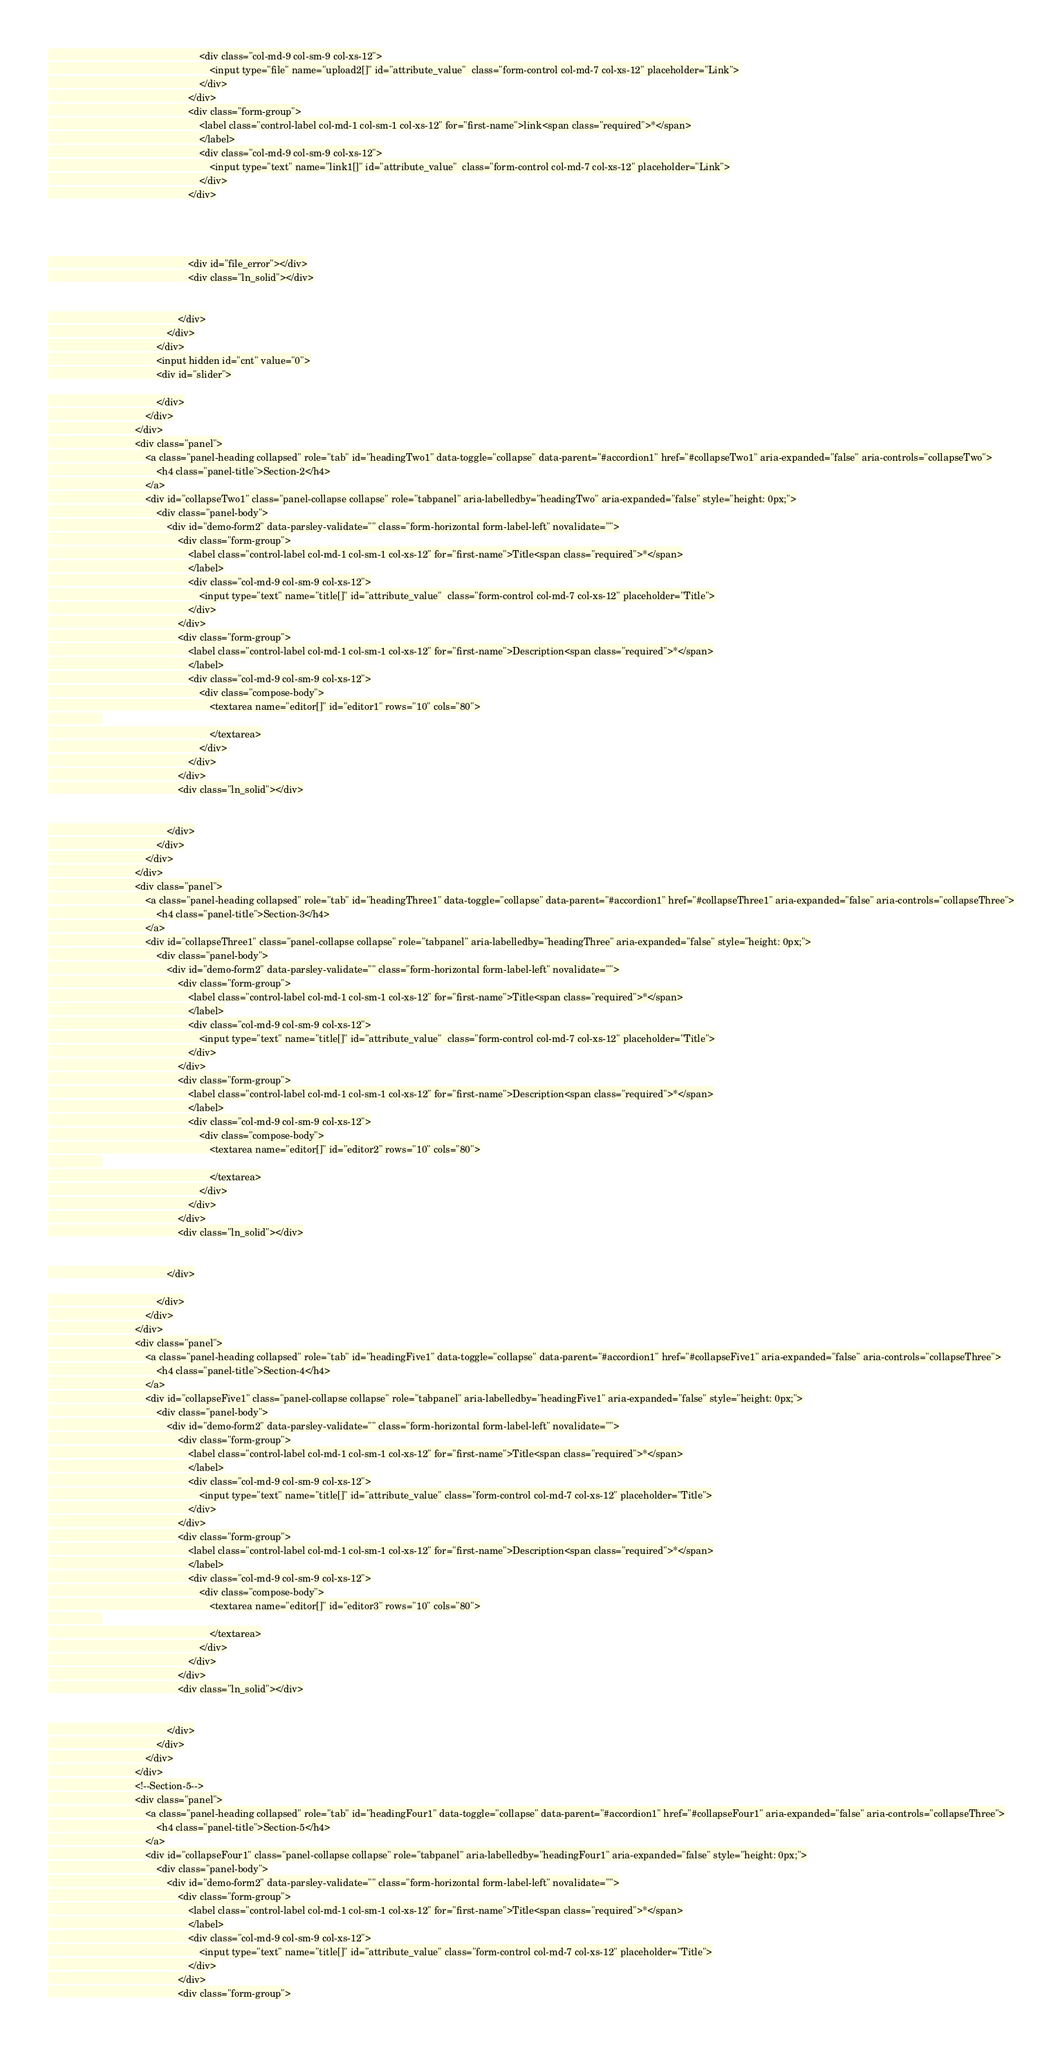Convert code to text. <code><loc_0><loc_0><loc_500><loc_500><_PHP_>                                                        <div class="col-md-9 col-sm-9 col-xs-12">
                                                            <input type="file" name="upload2[]" id="attribute_value"  class="form-control col-md-7 col-xs-12" placeholder="Link">
                                                        </div>
                                                    </div>
                                                    <div class="form-group">
                                                        <label class="control-label col-md-1 col-sm-1 col-xs-12" for="first-name">link<span class="required">*</span>
                                                        </label>
                                                        <div class="col-md-9 col-sm-9 col-xs-12">
                                                            <input type="text" name="link1[]" id="attribute_value"  class="form-control col-md-7 col-xs-12" placeholder="Link">
                                                        </div>
                                                    </div>




                                                    <div id="file_error"></div>
                                                    <div class="ln_solid"></div>


                                                </div>
                                            </div>
                                        </div>
                                        <input hidden id="cnt" value="0">
                                        <div id="slider">

                                        </div>
                                    </div>
                                </div>
                                <div class="panel">
                                    <a class="panel-heading collapsed" role="tab" id="headingTwo1" data-toggle="collapse" data-parent="#accordion1" href="#collapseTwo1" aria-expanded="false" aria-controls="collapseTwo">
                                        <h4 class="panel-title">Section-2</h4>
                                    </a>
                                    <div id="collapseTwo1" class="panel-collapse collapse" role="tabpanel" aria-labelledby="headingTwo" aria-expanded="false" style="height: 0px;">
                                        <div class="panel-body">
                                            <div id="demo-form2" data-parsley-validate="" class="form-horizontal form-label-left" novalidate="">
                                                <div class="form-group">
                                                    <label class="control-label col-md-1 col-sm-1 col-xs-12" for="first-name">Title<span class="required">*</span>
                                                    </label>
                                                    <div class="col-md-9 col-sm-9 col-xs-12">
                                                        <input type="text" name="title[]" id="attribute_value"  class="form-control col-md-7 col-xs-12" placeholder="Title">
                                                    </div>
                                                </div>
                                                <div class="form-group">
                                                    <label class="control-label col-md-1 col-sm-1 col-xs-12" for="first-name">Description<span class="required">*</span>
                                                    </label>
                                                    <div class="col-md-9 col-sm-9 col-xs-12">
                                                        <div class="compose-body">
                                                            <textarea name="editor[]" id="editor1" rows="10" cols="80">
                    
                                                            </textarea>
                                                        </div>
                                                    </div>
                                                </div>
                                                <div class="ln_solid"></div>


                                            </div>
                                        </div>
                                    </div>
                                </div>
                                <div class="panel">
                                    <a class="panel-heading collapsed" role="tab" id="headingThree1" data-toggle="collapse" data-parent="#accordion1" href="#collapseThree1" aria-expanded="false" aria-controls="collapseThree">
                                        <h4 class="panel-title">Section-3</h4>
                                    </a>
                                    <div id="collapseThree1" class="panel-collapse collapse" role="tabpanel" aria-labelledby="headingThree" aria-expanded="false" style="height: 0px;">
                                        <div class="panel-body">
                                            <div id="demo-form2" data-parsley-validate="" class="form-horizontal form-label-left" novalidate="">
                                                <div class="form-group">
                                                    <label class="control-label col-md-1 col-sm-1 col-xs-12" for="first-name">Title<span class="required">*</span>
                                                    </label>
                                                    <div class="col-md-9 col-sm-9 col-xs-12">
                                                        <input type="text" name="title[]" id="attribute_value"  class="form-control col-md-7 col-xs-12" placeholder="Title">
                                                    </div>
                                                </div>
                                                <div class="form-group">
                                                    <label class="control-label col-md-1 col-sm-1 col-xs-12" for="first-name">Description<span class="required">*</span>
                                                    </label>
                                                    <div class="col-md-9 col-sm-9 col-xs-12">
                                                        <div class="compose-body">
                                                            <textarea name="editor[]" id="editor2" rows="10" cols="80">
                    
                                                            </textarea>
                                                        </div>
                                                    </div>
                                                </div>
                                                <div class="ln_solid"></div>


                                            </div>

                                        </div>
                                    </div>
                                </div>
                                <div class="panel">
                                    <a class="panel-heading collapsed" role="tab" id="headingFive1" data-toggle="collapse" data-parent="#accordion1" href="#collapseFive1" aria-expanded="false" aria-controls="collapseThree">
                                        <h4 class="panel-title">Section-4</h4>
                                    </a>
                                    <div id="collapseFive1" class="panel-collapse collapse" role="tabpanel" aria-labelledby="headingFive1" aria-expanded="false" style="height: 0px;">
                                        <div class="panel-body">
                                            <div id="demo-form2" data-parsley-validate="" class="form-horizontal form-label-left" novalidate="">
                                                <div class="form-group">
                                                    <label class="control-label col-md-1 col-sm-1 col-xs-12" for="first-name">Title<span class="required">*</span>
                                                    </label>
                                                    <div class="col-md-9 col-sm-9 col-xs-12">
                                                        <input type="text" name="title[]" id="attribute_value" class="form-control col-md-7 col-xs-12" placeholder="Title">
                                                    </div>
                                                </div>
                                                <div class="form-group">
                                                    <label class="control-label col-md-1 col-sm-1 col-xs-12" for="first-name">Description<span class="required">*</span>
                                                    </label>
                                                    <div class="col-md-9 col-sm-9 col-xs-12">
                                                        <div class="compose-body">
                                                            <textarea name="editor[]" id="editor3" rows="10" cols="80">
                    
                                                            </textarea>
                                                        </div>
                                                    </div>
                                                </div>
                                                <div class="ln_solid"></div>


                                            </div>
                                        </div>
                                    </div>
                                </div>
                                <!--Section-5-->
                                <div class="panel">
                                    <a class="panel-heading collapsed" role="tab" id="headingFour1" data-toggle="collapse" data-parent="#accordion1" href="#collapseFour1" aria-expanded="false" aria-controls="collapseThree">
                                        <h4 class="panel-title">Section-5</h4>
                                    </a>
                                    <div id="collapseFour1" class="panel-collapse collapse" role="tabpanel" aria-labelledby="headingFour1" aria-expanded="false" style="height: 0px;">
                                        <div class="panel-body">
                                            <div id="demo-form2" data-parsley-validate="" class="form-horizontal form-label-left" novalidate="">
                                                <div class="form-group">
                                                    <label class="control-label col-md-1 col-sm-1 col-xs-12" for="first-name">Title<span class="required">*</span>
                                                    </label>
                                                    <div class="col-md-9 col-sm-9 col-xs-12">
                                                        <input type="text" name="title[]" id="attribute_value" class="form-control col-md-7 col-xs-12" placeholder="Title">
                                                    </div>
                                                </div>
                                                <div class="form-group"></code> 